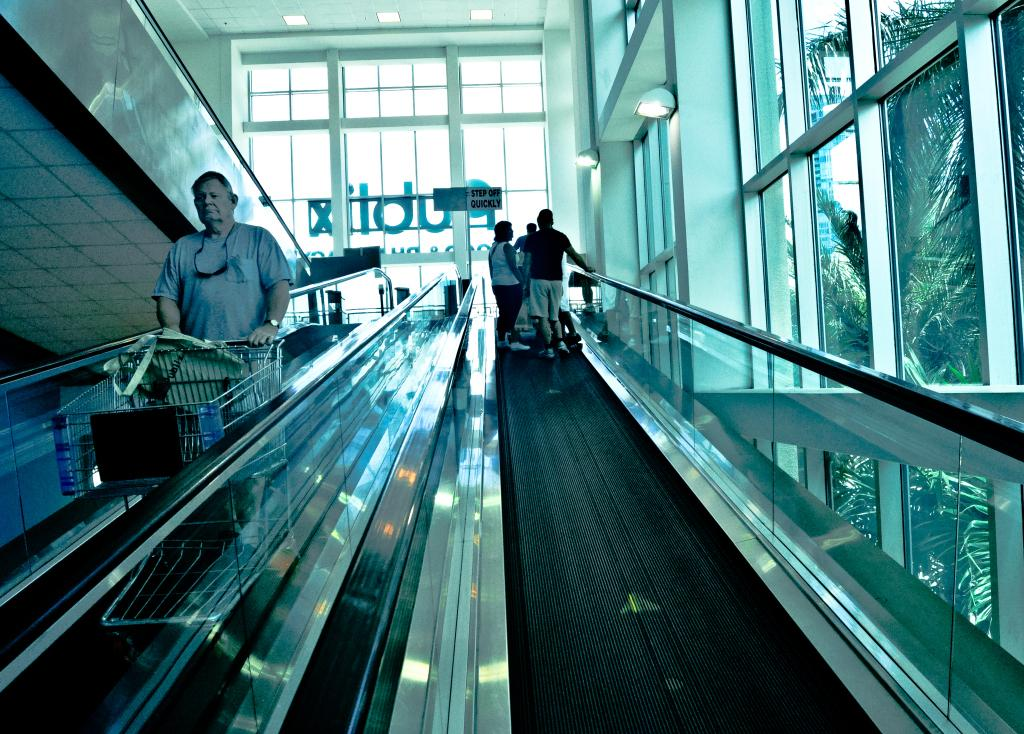<image>
Give a short and clear explanation of the subsequent image. A sign at the end of the escalator indicates to step off quickly. 